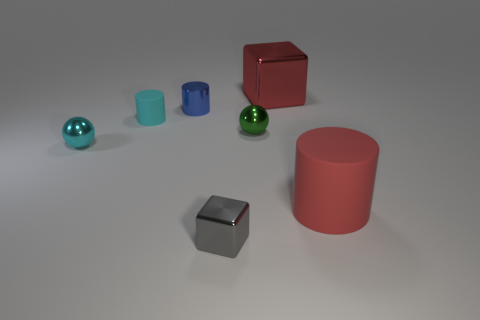Subtract all large matte cylinders. How many cylinders are left? 2 Add 1 matte objects. How many objects exist? 8 Subtract all balls. How many objects are left? 5 Add 4 small metal cylinders. How many small metal cylinders are left? 5 Add 6 purple cubes. How many purple cubes exist? 6 Subtract 0 gray cylinders. How many objects are left? 7 Subtract all purple cylinders. Subtract all gray balls. How many cylinders are left? 3 Subtract all brown things. Subtract all cyan metallic spheres. How many objects are left? 6 